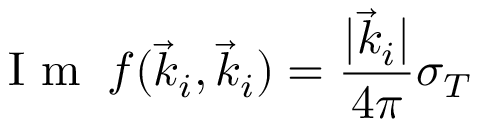<formula> <loc_0><loc_0><loc_500><loc_500>I m \, f ( \vec { k } _ { i } , \vec { k } _ { i } ) = \frac { | \vec { k } _ { i } | } { 4 \pi } \sigma _ { T }</formula> 